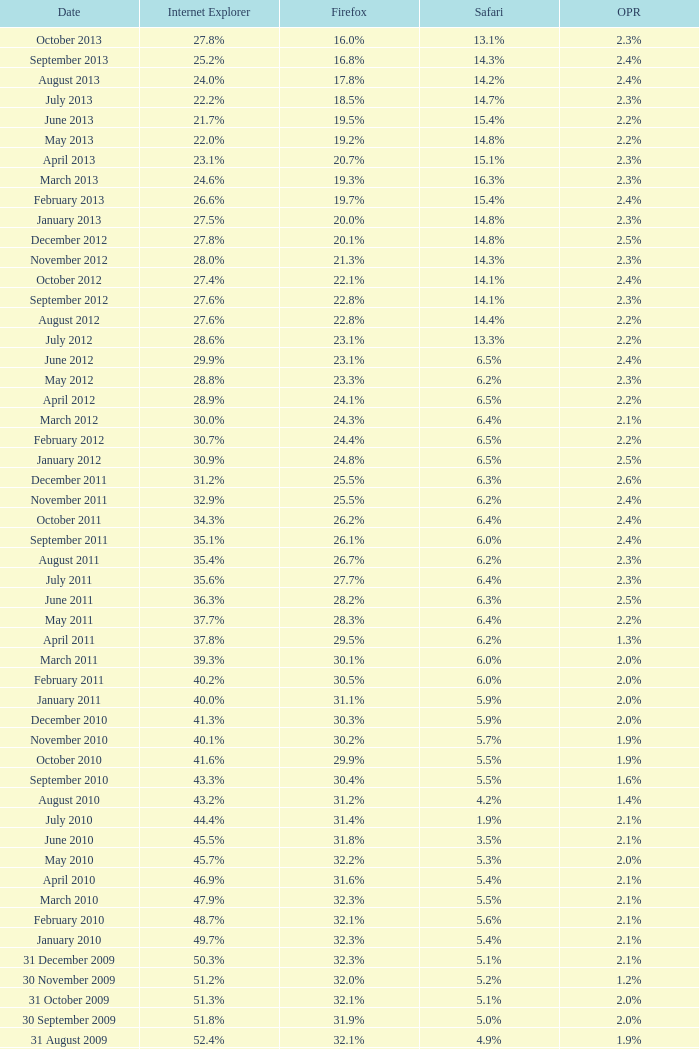What is the firefox value with a 1.8% opera on 30 July 2007? 25.1%. 